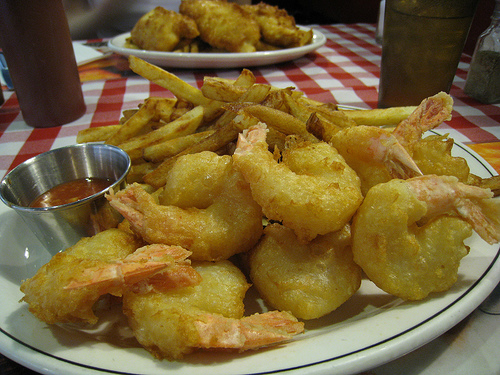<image>
Is the shrimp behind the plate? No. The shrimp is not behind the plate. From this viewpoint, the shrimp appears to be positioned elsewhere in the scene. 